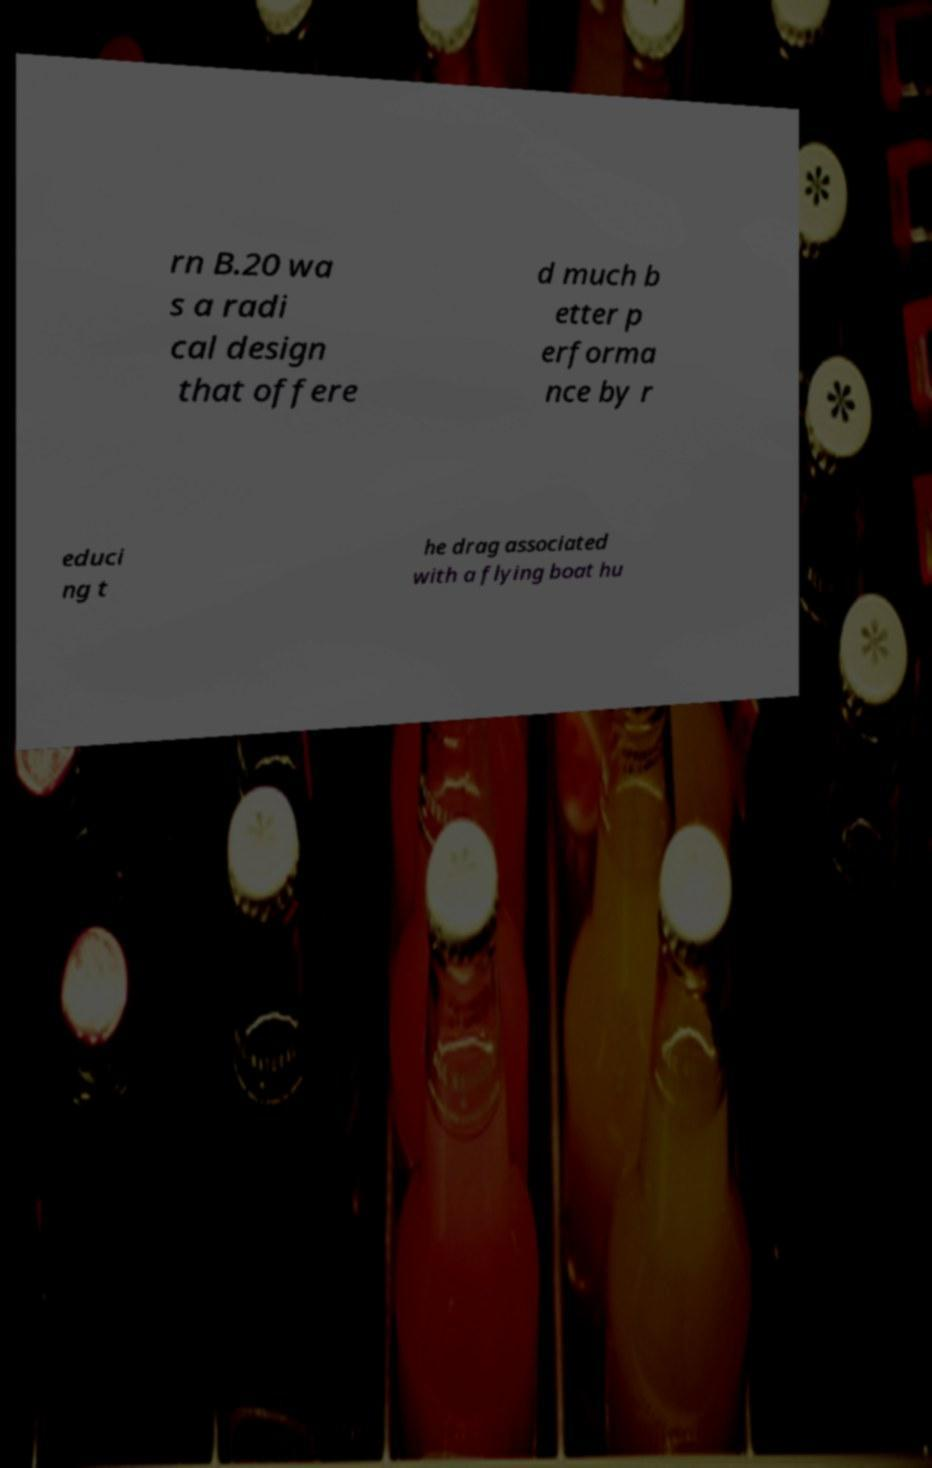What messages or text are displayed in this image? I need them in a readable, typed format. rn B.20 wa s a radi cal design that offere d much b etter p erforma nce by r educi ng t he drag associated with a flying boat hu 